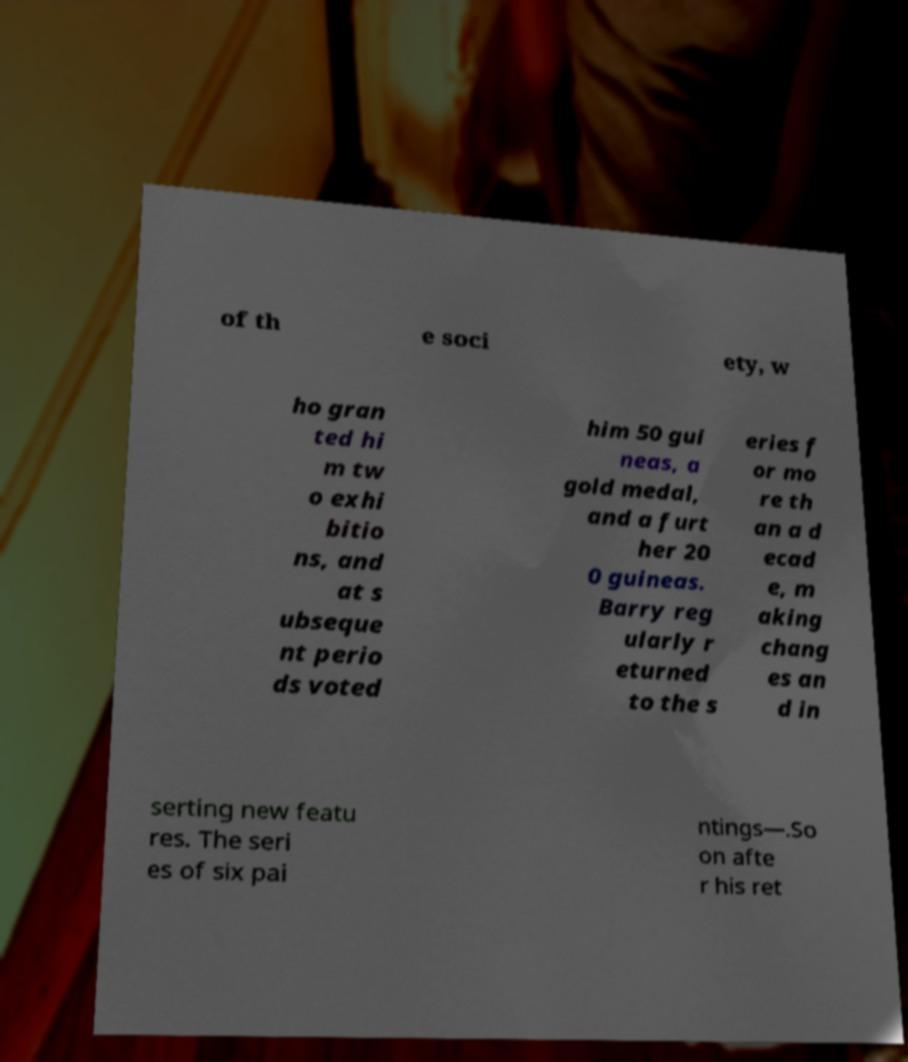Could you assist in decoding the text presented in this image and type it out clearly? of th e soci ety, w ho gran ted hi m tw o exhi bitio ns, and at s ubseque nt perio ds voted him 50 gui neas, a gold medal, and a furt her 20 0 guineas. Barry reg ularly r eturned to the s eries f or mo re th an a d ecad e, m aking chang es an d in serting new featu res. The seri es of six pai ntings—.So on afte r his ret 